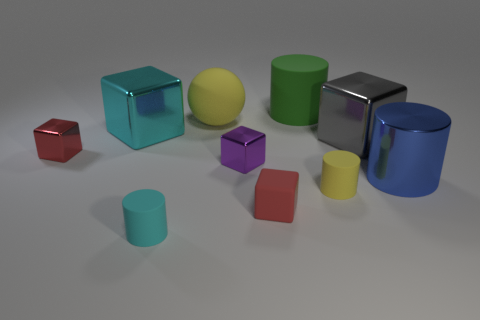Is the number of things in front of the large gray metallic thing less than the number of objects that are in front of the large green matte thing?
Keep it short and to the point. Yes. There is a gray metal block; is it the same size as the cylinder behind the large gray shiny block?
Your answer should be very brief. Yes. How many purple metal cubes have the same size as the purple thing?
Give a very brief answer. 0. There is a large cylinder that is made of the same material as the big ball; what is its color?
Offer a very short reply. Green. Are there more red matte blocks than small red metal balls?
Offer a very short reply. Yes. Do the blue thing and the small yellow cylinder have the same material?
Your answer should be compact. No. There is a purple thing that is the same material as the large gray thing; what shape is it?
Offer a terse response. Cube. Are there fewer tiny red objects than rubber things?
Ensure brevity in your answer.  Yes. What is the material of the object that is to the left of the tiny red rubber cube and in front of the small purple thing?
Offer a terse response. Rubber. There is a yellow rubber thing in front of the large cylinder right of the cube that is right of the yellow matte cylinder; what is its size?
Make the answer very short. Small. 